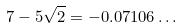<formula> <loc_0><loc_0><loc_500><loc_500>7 - 5 \sqrt { 2 } = - 0 . 0 7 1 0 6 \dots</formula> 